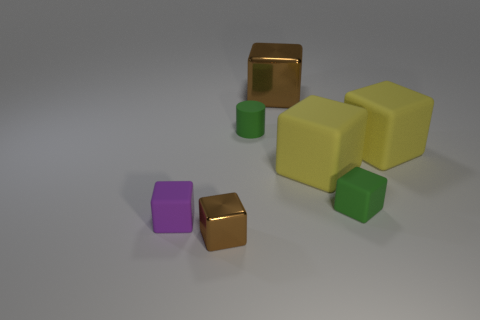There is a block that is both behind the tiny brown cube and on the left side of the matte cylinder; what size is it?
Your answer should be very brief. Small. How many rubber things are either yellow blocks or small purple things?
Offer a very short reply. 3. Does the brown object that is behind the small green matte block have the same shape as the small green thing in front of the green matte cylinder?
Keep it short and to the point. Yes. Is there a purple thing made of the same material as the tiny purple cube?
Your answer should be compact. No. What color is the small metal block?
Your answer should be compact. Brown. What is the size of the brown thing that is in front of the large brown thing?
Your answer should be very brief. Small. What number of tiny rubber things have the same color as the tiny metallic block?
Provide a short and direct response. 0. Are there any small green blocks that are behind the brown metallic thing behind the small green cylinder?
Your answer should be very brief. No. There is a tiny rubber block that is right of the purple matte block; does it have the same color as the large rubber cube on the right side of the tiny green matte block?
Give a very brief answer. No. The rubber cube that is the same size as the purple matte object is what color?
Make the answer very short. Green. 